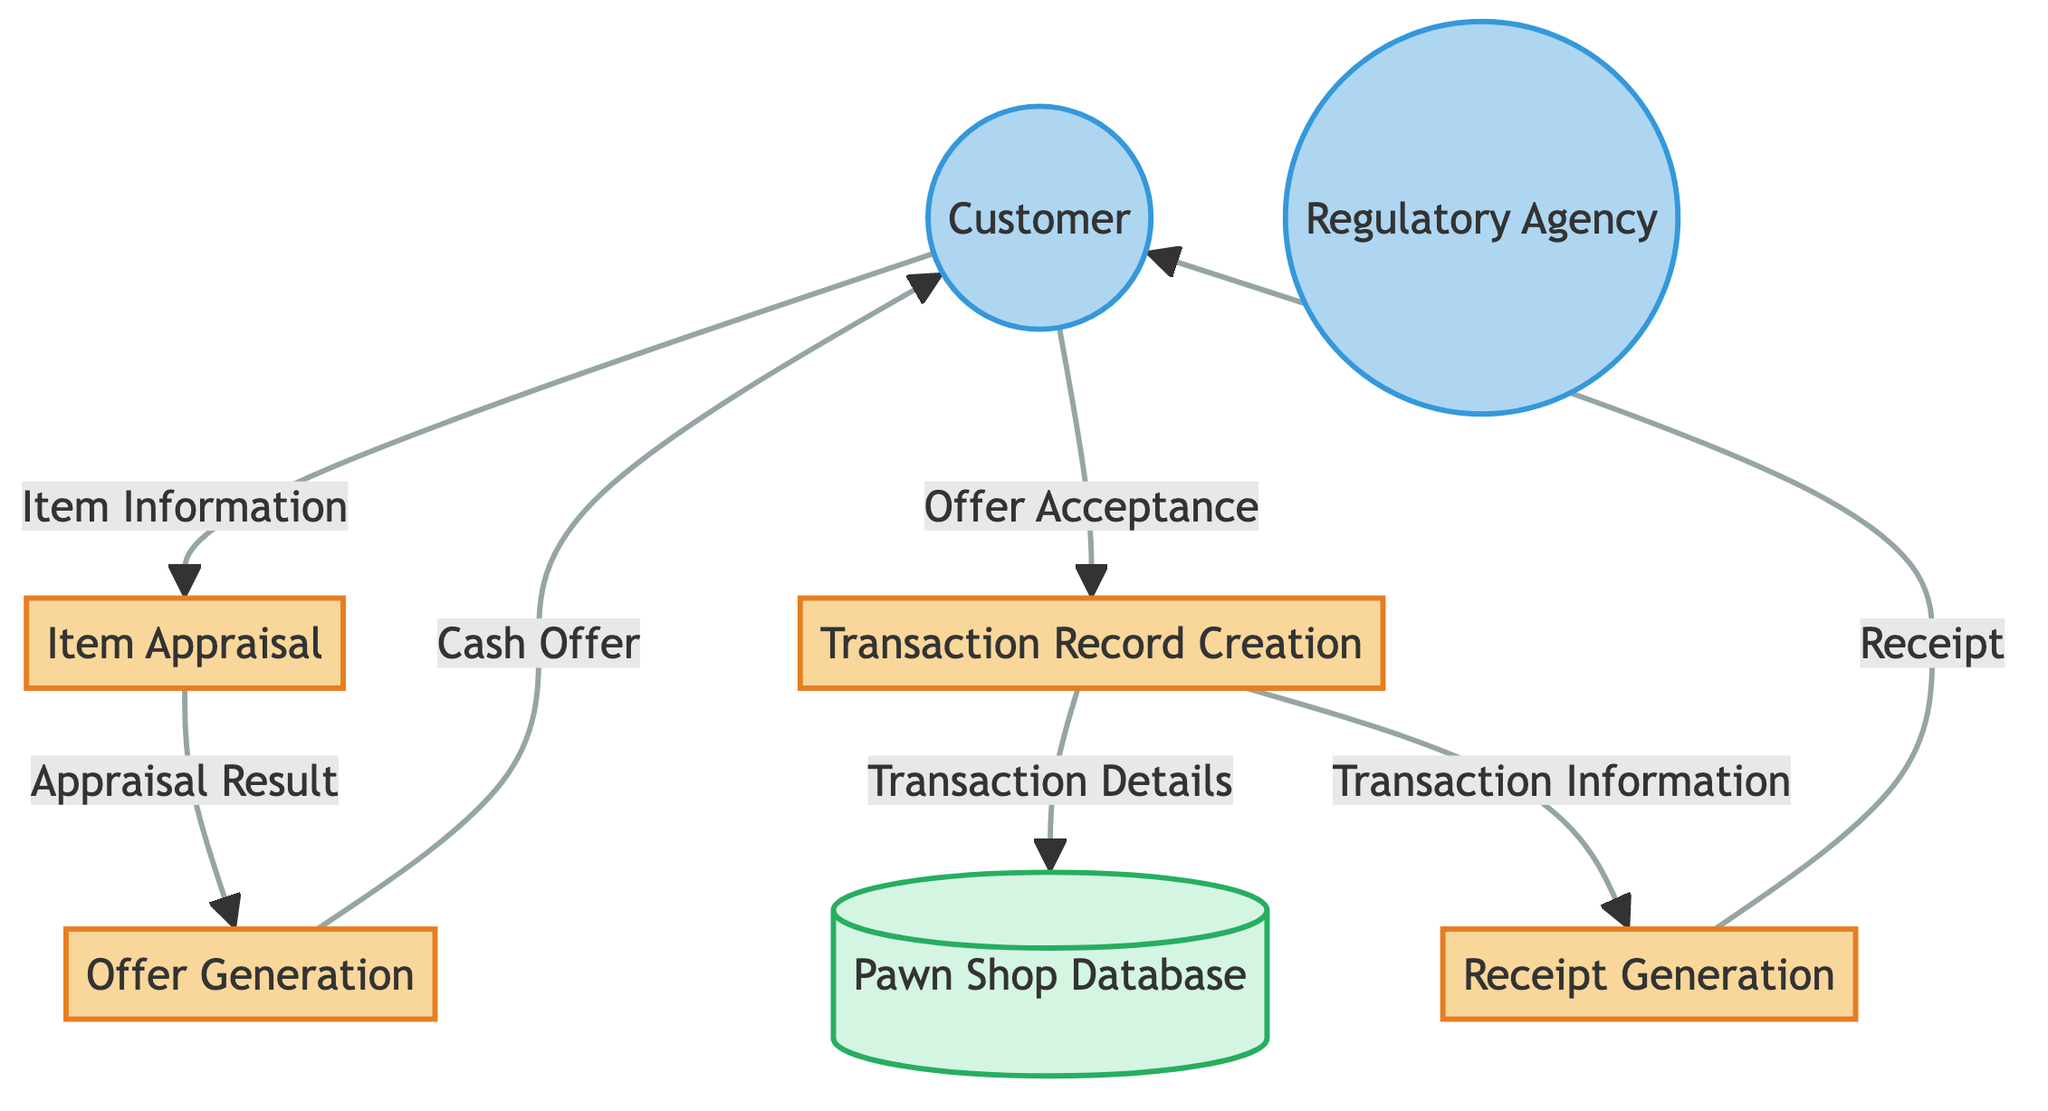What is the first process in the diagram? The diagram shows the flow starting from the "Customer" leading to "Item Appraisal," which is the first process.
Answer: Item Appraisal How many data flows are represented in the diagram? The diagram illustrates a total of seven data flows that connect various entities and processes.
Answer: Seven What does the "Offer Generation" process output to the customer? The "Offer Generation" process generates a "Cash Offer" that is sent to the "Customer" after evaluating the appraised value of the item.
Answer: Cash Offer What information does the "Transaction Record Creation" send to the Pawn Shop Database? The information sent from "Transaction Record Creation" to the "Pawn Shop Database" is referred to as "Transaction Details," which includes essential transaction-related data.
Answer: Transaction Details Which entity receives the final output from the "Receipt Generation" process? The final output of the "Receipt Generation" process is sent to the "Customer" as a receipt detailing their transaction.
Answer: Customer If the customer does not accept the cash offer, which process do they not engage with? If the customer does not accept the cash offer generated in the "Offer Generation" process, they do not proceed to the "Transaction Record Creation" process.
Answer: Transaction Record Creation What type of agency is represented as an external entity in the diagram? The external entity in the diagram is labeled as a "Regulatory Agency," which may require reports regarding transaction details.
Answer: Regulatory Agency What is the main purpose of the "Receipt Generation" process? The main purpose of the "Receipt Generation" process is to produce a receipt that provides the customer with detailed information regarding their transaction.
Answer: Receipt 